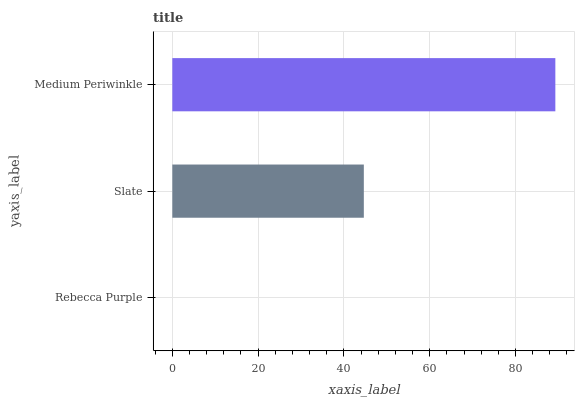Is Rebecca Purple the minimum?
Answer yes or no. Yes. Is Medium Periwinkle the maximum?
Answer yes or no. Yes. Is Slate the minimum?
Answer yes or no. No. Is Slate the maximum?
Answer yes or no. No. Is Slate greater than Rebecca Purple?
Answer yes or no. Yes. Is Rebecca Purple less than Slate?
Answer yes or no. Yes. Is Rebecca Purple greater than Slate?
Answer yes or no. No. Is Slate less than Rebecca Purple?
Answer yes or no. No. Is Slate the high median?
Answer yes or no. Yes. Is Slate the low median?
Answer yes or no. Yes. Is Rebecca Purple the high median?
Answer yes or no. No. Is Rebecca Purple the low median?
Answer yes or no. No. 